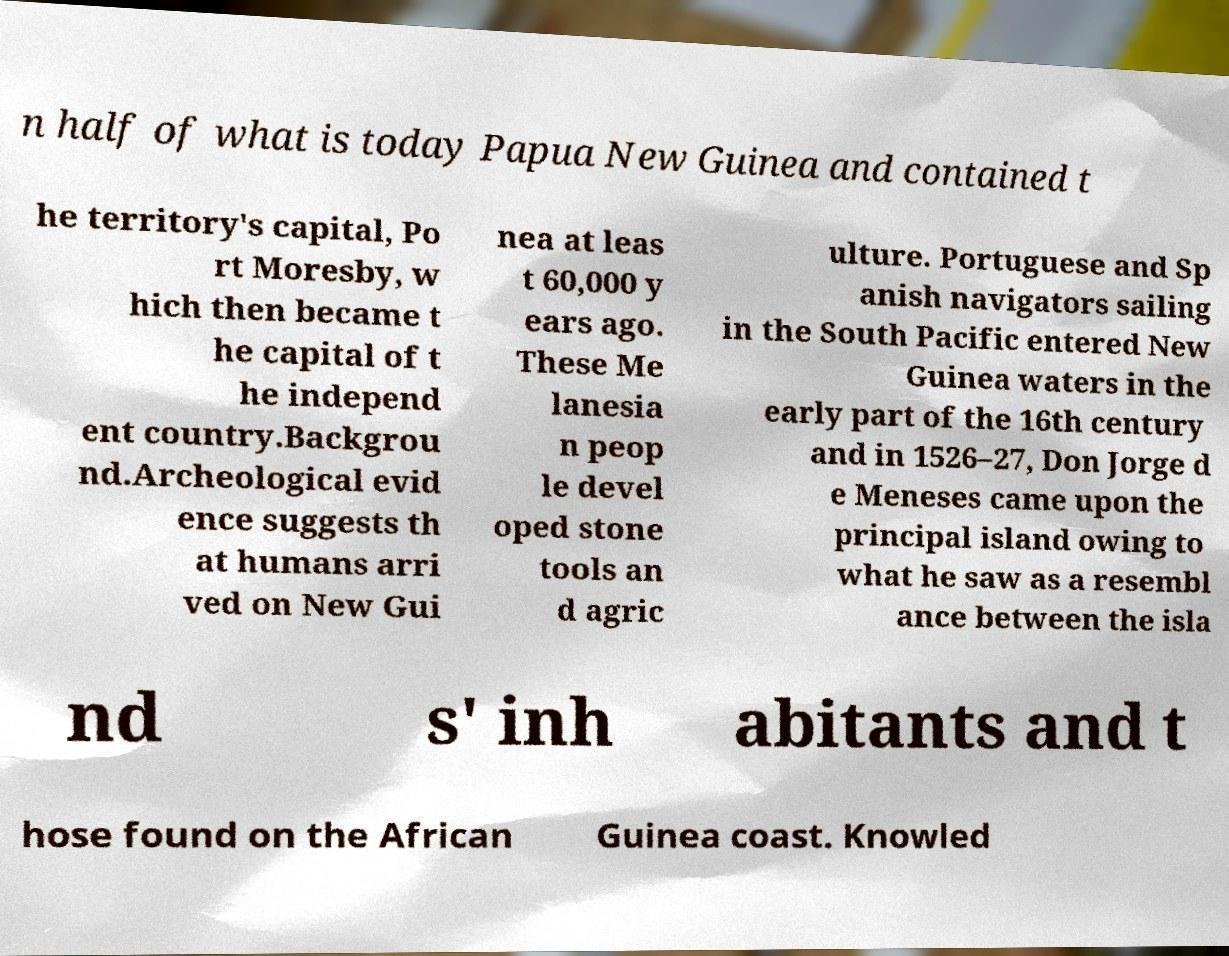Could you extract and type out the text from this image? n half of what is today Papua New Guinea and contained t he territory's capital, Po rt Moresby, w hich then became t he capital of t he independ ent country.Backgrou nd.Archeological evid ence suggests th at humans arri ved on New Gui nea at leas t 60,000 y ears ago. These Me lanesia n peop le devel oped stone tools an d agric ulture. Portuguese and Sp anish navigators sailing in the South Pacific entered New Guinea waters in the early part of the 16th century and in 1526–27, Don Jorge d e Meneses came upon the principal island owing to what he saw as a resembl ance between the isla nd s' inh abitants and t hose found on the African Guinea coast. Knowled 